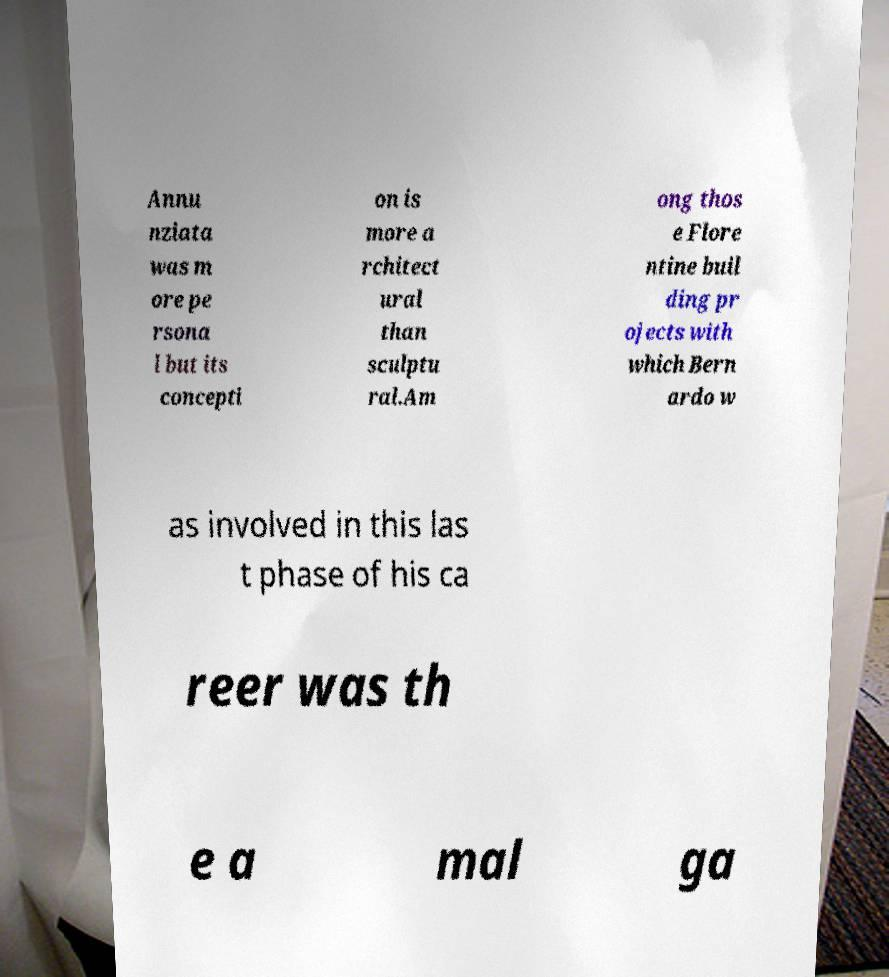What messages or text are displayed in this image? I need them in a readable, typed format. Annu nziata was m ore pe rsona l but its concepti on is more a rchitect ural than sculptu ral.Am ong thos e Flore ntine buil ding pr ojects with which Bern ardo w as involved in this las t phase of his ca reer was th e a mal ga 